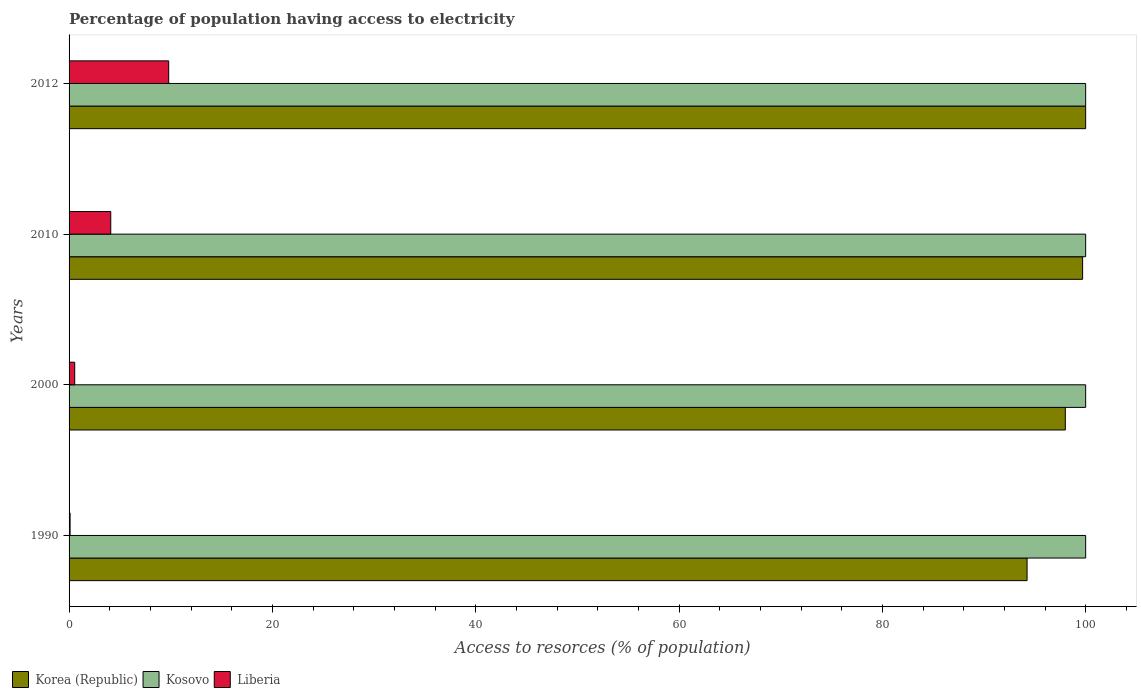How many different coloured bars are there?
Your response must be concise. 3. Are the number of bars per tick equal to the number of legend labels?
Keep it short and to the point. Yes. Are the number of bars on each tick of the Y-axis equal?
Make the answer very short. Yes. How many bars are there on the 1st tick from the top?
Offer a terse response. 3. What is the percentage of population having access to electricity in Kosovo in 2010?
Ensure brevity in your answer.  100. Across all years, what is the minimum percentage of population having access to electricity in Kosovo?
Keep it short and to the point. 100. In which year was the percentage of population having access to electricity in Liberia maximum?
Make the answer very short. 2012. What is the total percentage of population having access to electricity in Liberia in the graph?
Offer a terse response. 14.56. What is the difference between the percentage of population having access to electricity in Liberia in 1990 and the percentage of population having access to electricity in Korea (Republic) in 2010?
Keep it short and to the point. -99.6. What is the average percentage of population having access to electricity in Liberia per year?
Give a very brief answer. 3.64. In the year 2012, what is the difference between the percentage of population having access to electricity in Korea (Republic) and percentage of population having access to electricity in Liberia?
Offer a very short reply. 90.2. What is the ratio of the percentage of population having access to electricity in Liberia in 1990 to that in 2012?
Provide a succinct answer. 0.01. What is the difference between the highest and the second highest percentage of population having access to electricity in Korea (Republic)?
Your response must be concise. 0.3. What is the difference between the highest and the lowest percentage of population having access to electricity in Liberia?
Your answer should be compact. 9.7. What does the 2nd bar from the bottom in 2010 represents?
Offer a terse response. Kosovo. How many bars are there?
Provide a short and direct response. 12. What is the difference between two consecutive major ticks on the X-axis?
Your answer should be very brief. 20. Does the graph contain any zero values?
Make the answer very short. No. Does the graph contain grids?
Offer a terse response. No. What is the title of the graph?
Keep it short and to the point. Percentage of population having access to electricity. Does "Congo (Republic)" appear as one of the legend labels in the graph?
Your answer should be compact. No. What is the label or title of the X-axis?
Keep it short and to the point. Access to resorces (% of population). What is the label or title of the Y-axis?
Provide a succinct answer. Years. What is the Access to resorces (% of population) in Korea (Republic) in 1990?
Your answer should be very brief. 94.24. What is the Access to resorces (% of population) of Kosovo in 1990?
Keep it short and to the point. 100. What is the Access to resorces (% of population) of Liberia in 1990?
Your answer should be compact. 0.1. What is the Access to resorces (% of population) of Korea (Republic) in 2000?
Provide a short and direct response. 98. What is the Access to resorces (% of population) in Kosovo in 2000?
Your response must be concise. 100. What is the Access to resorces (% of population) in Liberia in 2000?
Your answer should be compact. 0.56. What is the Access to resorces (% of population) of Korea (Republic) in 2010?
Give a very brief answer. 99.7. What is the Access to resorces (% of population) of Liberia in 2012?
Offer a terse response. 9.8. Across all years, what is the maximum Access to resorces (% of population) of Korea (Republic)?
Offer a terse response. 100. Across all years, what is the minimum Access to resorces (% of population) of Korea (Republic)?
Make the answer very short. 94.24. Across all years, what is the minimum Access to resorces (% of population) in Kosovo?
Give a very brief answer. 100. Across all years, what is the minimum Access to resorces (% of population) in Liberia?
Offer a very short reply. 0.1. What is the total Access to resorces (% of population) of Korea (Republic) in the graph?
Make the answer very short. 391.94. What is the total Access to resorces (% of population) in Liberia in the graph?
Keep it short and to the point. 14.56. What is the difference between the Access to resorces (% of population) in Korea (Republic) in 1990 and that in 2000?
Provide a succinct answer. -3.76. What is the difference between the Access to resorces (% of population) of Liberia in 1990 and that in 2000?
Keep it short and to the point. -0.46. What is the difference between the Access to resorces (% of population) in Korea (Republic) in 1990 and that in 2010?
Give a very brief answer. -5.46. What is the difference between the Access to resorces (% of population) of Kosovo in 1990 and that in 2010?
Your answer should be very brief. 0. What is the difference between the Access to resorces (% of population) in Korea (Republic) in 1990 and that in 2012?
Keep it short and to the point. -5.76. What is the difference between the Access to resorces (% of population) in Kosovo in 1990 and that in 2012?
Make the answer very short. 0. What is the difference between the Access to resorces (% of population) of Liberia in 1990 and that in 2012?
Your answer should be compact. -9.7. What is the difference between the Access to resorces (% of population) in Kosovo in 2000 and that in 2010?
Make the answer very short. 0. What is the difference between the Access to resorces (% of population) of Liberia in 2000 and that in 2010?
Make the answer very short. -3.54. What is the difference between the Access to resorces (% of population) in Korea (Republic) in 2000 and that in 2012?
Keep it short and to the point. -2. What is the difference between the Access to resorces (% of population) of Liberia in 2000 and that in 2012?
Give a very brief answer. -9.24. What is the difference between the Access to resorces (% of population) of Korea (Republic) in 2010 and that in 2012?
Your response must be concise. -0.3. What is the difference between the Access to resorces (% of population) in Kosovo in 2010 and that in 2012?
Provide a short and direct response. 0. What is the difference between the Access to resorces (% of population) in Liberia in 2010 and that in 2012?
Your answer should be compact. -5.7. What is the difference between the Access to resorces (% of population) of Korea (Republic) in 1990 and the Access to resorces (% of population) of Kosovo in 2000?
Your answer should be compact. -5.76. What is the difference between the Access to resorces (% of population) in Korea (Republic) in 1990 and the Access to resorces (% of population) in Liberia in 2000?
Make the answer very short. 93.68. What is the difference between the Access to resorces (% of population) of Kosovo in 1990 and the Access to resorces (% of population) of Liberia in 2000?
Offer a very short reply. 99.44. What is the difference between the Access to resorces (% of population) of Korea (Republic) in 1990 and the Access to resorces (% of population) of Kosovo in 2010?
Provide a short and direct response. -5.76. What is the difference between the Access to resorces (% of population) in Korea (Republic) in 1990 and the Access to resorces (% of population) in Liberia in 2010?
Make the answer very short. 90.14. What is the difference between the Access to resorces (% of population) in Kosovo in 1990 and the Access to resorces (% of population) in Liberia in 2010?
Offer a very short reply. 95.9. What is the difference between the Access to resorces (% of population) in Korea (Republic) in 1990 and the Access to resorces (% of population) in Kosovo in 2012?
Your answer should be very brief. -5.76. What is the difference between the Access to resorces (% of population) in Korea (Republic) in 1990 and the Access to resorces (% of population) in Liberia in 2012?
Provide a short and direct response. 84.44. What is the difference between the Access to resorces (% of population) of Kosovo in 1990 and the Access to resorces (% of population) of Liberia in 2012?
Offer a very short reply. 90.2. What is the difference between the Access to resorces (% of population) in Korea (Republic) in 2000 and the Access to resorces (% of population) in Kosovo in 2010?
Ensure brevity in your answer.  -2. What is the difference between the Access to resorces (% of population) in Korea (Republic) in 2000 and the Access to resorces (% of population) in Liberia in 2010?
Make the answer very short. 93.9. What is the difference between the Access to resorces (% of population) in Kosovo in 2000 and the Access to resorces (% of population) in Liberia in 2010?
Provide a short and direct response. 95.9. What is the difference between the Access to resorces (% of population) in Korea (Republic) in 2000 and the Access to resorces (% of population) in Kosovo in 2012?
Offer a very short reply. -2. What is the difference between the Access to resorces (% of population) in Korea (Republic) in 2000 and the Access to resorces (% of population) in Liberia in 2012?
Your answer should be very brief. 88.2. What is the difference between the Access to resorces (% of population) in Kosovo in 2000 and the Access to resorces (% of population) in Liberia in 2012?
Your answer should be compact. 90.2. What is the difference between the Access to resorces (% of population) in Korea (Republic) in 2010 and the Access to resorces (% of population) in Kosovo in 2012?
Give a very brief answer. -0.3. What is the difference between the Access to resorces (% of population) in Korea (Republic) in 2010 and the Access to resorces (% of population) in Liberia in 2012?
Offer a very short reply. 89.9. What is the difference between the Access to resorces (% of population) in Kosovo in 2010 and the Access to resorces (% of population) in Liberia in 2012?
Your response must be concise. 90.2. What is the average Access to resorces (% of population) in Korea (Republic) per year?
Provide a short and direct response. 97.98. What is the average Access to resorces (% of population) in Liberia per year?
Your answer should be compact. 3.64. In the year 1990, what is the difference between the Access to resorces (% of population) of Korea (Republic) and Access to resorces (% of population) of Kosovo?
Give a very brief answer. -5.76. In the year 1990, what is the difference between the Access to resorces (% of population) in Korea (Republic) and Access to resorces (% of population) in Liberia?
Keep it short and to the point. 94.14. In the year 1990, what is the difference between the Access to resorces (% of population) of Kosovo and Access to resorces (% of population) of Liberia?
Offer a very short reply. 99.9. In the year 2000, what is the difference between the Access to resorces (% of population) in Korea (Republic) and Access to resorces (% of population) in Kosovo?
Your answer should be compact. -2. In the year 2000, what is the difference between the Access to resorces (% of population) in Korea (Republic) and Access to resorces (% of population) in Liberia?
Offer a terse response. 97.44. In the year 2000, what is the difference between the Access to resorces (% of population) in Kosovo and Access to resorces (% of population) in Liberia?
Offer a very short reply. 99.44. In the year 2010, what is the difference between the Access to resorces (% of population) of Korea (Republic) and Access to resorces (% of population) of Liberia?
Keep it short and to the point. 95.6. In the year 2010, what is the difference between the Access to resorces (% of population) in Kosovo and Access to resorces (% of population) in Liberia?
Offer a very short reply. 95.9. In the year 2012, what is the difference between the Access to resorces (% of population) in Korea (Republic) and Access to resorces (% of population) in Liberia?
Keep it short and to the point. 90.2. In the year 2012, what is the difference between the Access to resorces (% of population) in Kosovo and Access to resorces (% of population) in Liberia?
Your answer should be compact. 90.2. What is the ratio of the Access to resorces (% of population) in Korea (Republic) in 1990 to that in 2000?
Provide a succinct answer. 0.96. What is the ratio of the Access to resorces (% of population) of Liberia in 1990 to that in 2000?
Offer a terse response. 0.18. What is the ratio of the Access to resorces (% of population) of Korea (Republic) in 1990 to that in 2010?
Your answer should be very brief. 0.95. What is the ratio of the Access to resorces (% of population) of Liberia in 1990 to that in 2010?
Your answer should be compact. 0.02. What is the ratio of the Access to resorces (% of population) of Korea (Republic) in 1990 to that in 2012?
Keep it short and to the point. 0.94. What is the ratio of the Access to resorces (% of population) of Liberia in 1990 to that in 2012?
Your response must be concise. 0.01. What is the ratio of the Access to resorces (% of population) of Korea (Republic) in 2000 to that in 2010?
Make the answer very short. 0.98. What is the ratio of the Access to resorces (% of population) of Kosovo in 2000 to that in 2010?
Offer a terse response. 1. What is the ratio of the Access to resorces (% of population) of Liberia in 2000 to that in 2010?
Your response must be concise. 0.14. What is the ratio of the Access to resorces (% of population) of Liberia in 2000 to that in 2012?
Ensure brevity in your answer.  0.06. What is the ratio of the Access to resorces (% of population) in Liberia in 2010 to that in 2012?
Offer a terse response. 0.42. What is the difference between the highest and the second highest Access to resorces (% of population) of Korea (Republic)?
Make the answer very short. 0.3. What is the difference between the highest and the second highest Access to resorces (% of population) of Kosovo?
Provide a succinct answer. 0. What is the difference between the highest and the lowest Access to resorces (% of population) in Korea (Republic)?
Your response must be concise. 5.76. What is the difference between the highest and the lowest Access to resorces (% of population) of Liberia?
Make the answer very short. 9.7. 